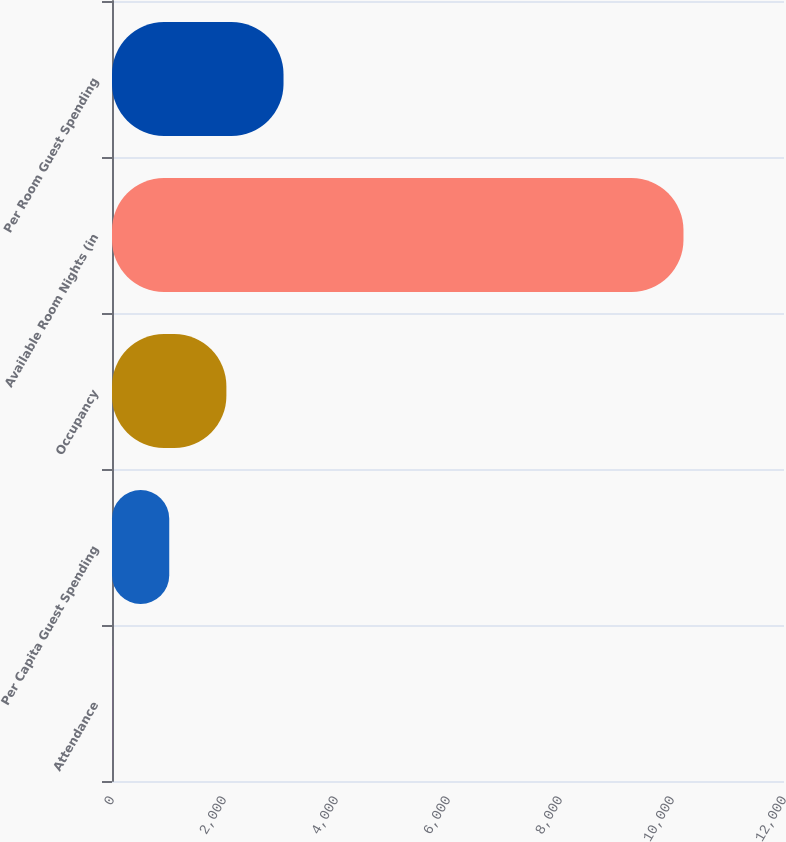Convert chart. <chart><loc_0><loc_0><loc_500><loc_500><bar_chart><fcel>Attendance<fcel>Per Capita Guest Spending<fcel>Occupancy<fcel>Available Room Nights (in<fcel>Per Room Guest Spending<nl><fcel>2<fcel>1022.3<fcel>2042.6<fcel>10205<fcel>3062.9<nl></chart> 